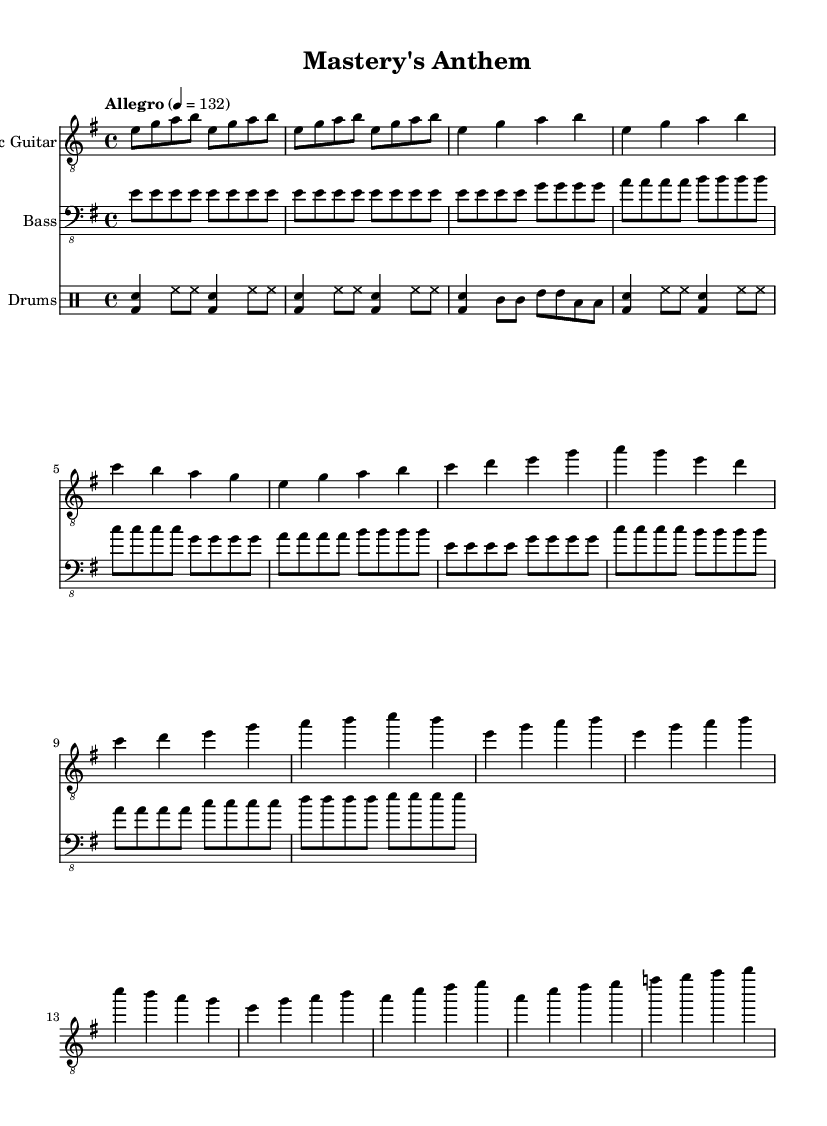What is the key signature of this music? The key signature is E minor, which has one sharp (F#). You can determine the key signature by identifying the key indicated in the global section of the code.
Answer: E minor What is the time signature of this music? The time signature is 4/4, as stated in the global section of the code. This means there are four beats in each measure and the quarter note receives one beat.
Answer: 4/4 What is the tempo marking for this piece? The tempo marking is Allegro, which indicates a fast tempo and is specified in the global section of the code with a metronome marking of 132 beats per minute.
Answer: Allegro How many measures are in the chorus section? The chorus section has two measures, which can be identified by counting the measures specifically labeled under the chorus part in the electric guitar section.
Answer: 2 What rhythmic feature characterizes the drum part in this piece? The drum part features a basic rock beat that includes bass drum and snare hits paired with hi-hat accents. This can be observed through the repeated patterns in the drummode section.
Answer: Basic rock beat What is the highest note played by the electric guitar? The highest note played by the electric guitar is B. This is determined by examining the melody played in the electric guitar section, specifically the highest pitch played in the verses and chorus.
Answer: B What element makes this anthem celebratory in nature? The anthem's celebratory nature is characterized by its energetic tempo and the use of power chords in the melody, which is common in high-energy rock anthems, and evident through the music structure and dynamics indicated in the score.
Answer: Energetic tempo 